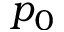Convert formula to latex. <formula><loc_0><loc_0><loc_500><loc_500>p _ { 0 }</formula> 